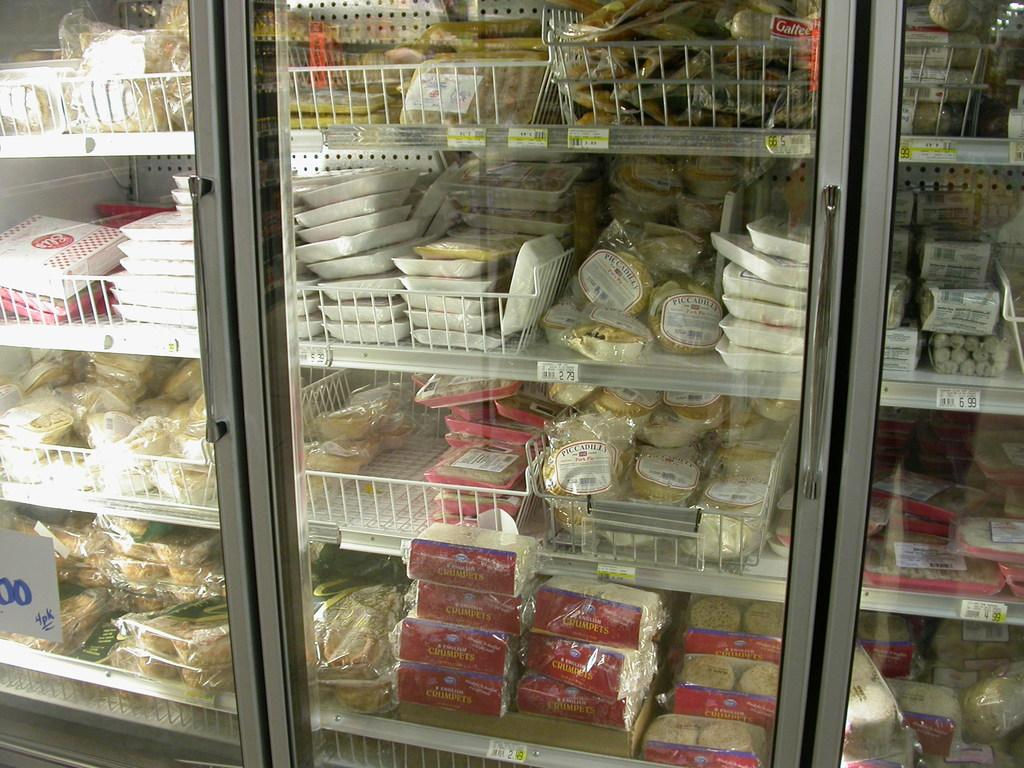What type of objects can be seen in the image? There are boxes, packets, and food items in the image. Where are these objects located? The objects are present on the racks in the image. Is there any labeling or identification on any of the objects? Yes, there is a sticker on a glass door in the image. What type of magic is being performed with the yoke in the image? There is no yoke or magic present in the image. How does the property owner maintain the cleanliness of the objects in the image? The provided facts do not mention any property owner or cleaning methods, so we cannot answer this question definitively. 